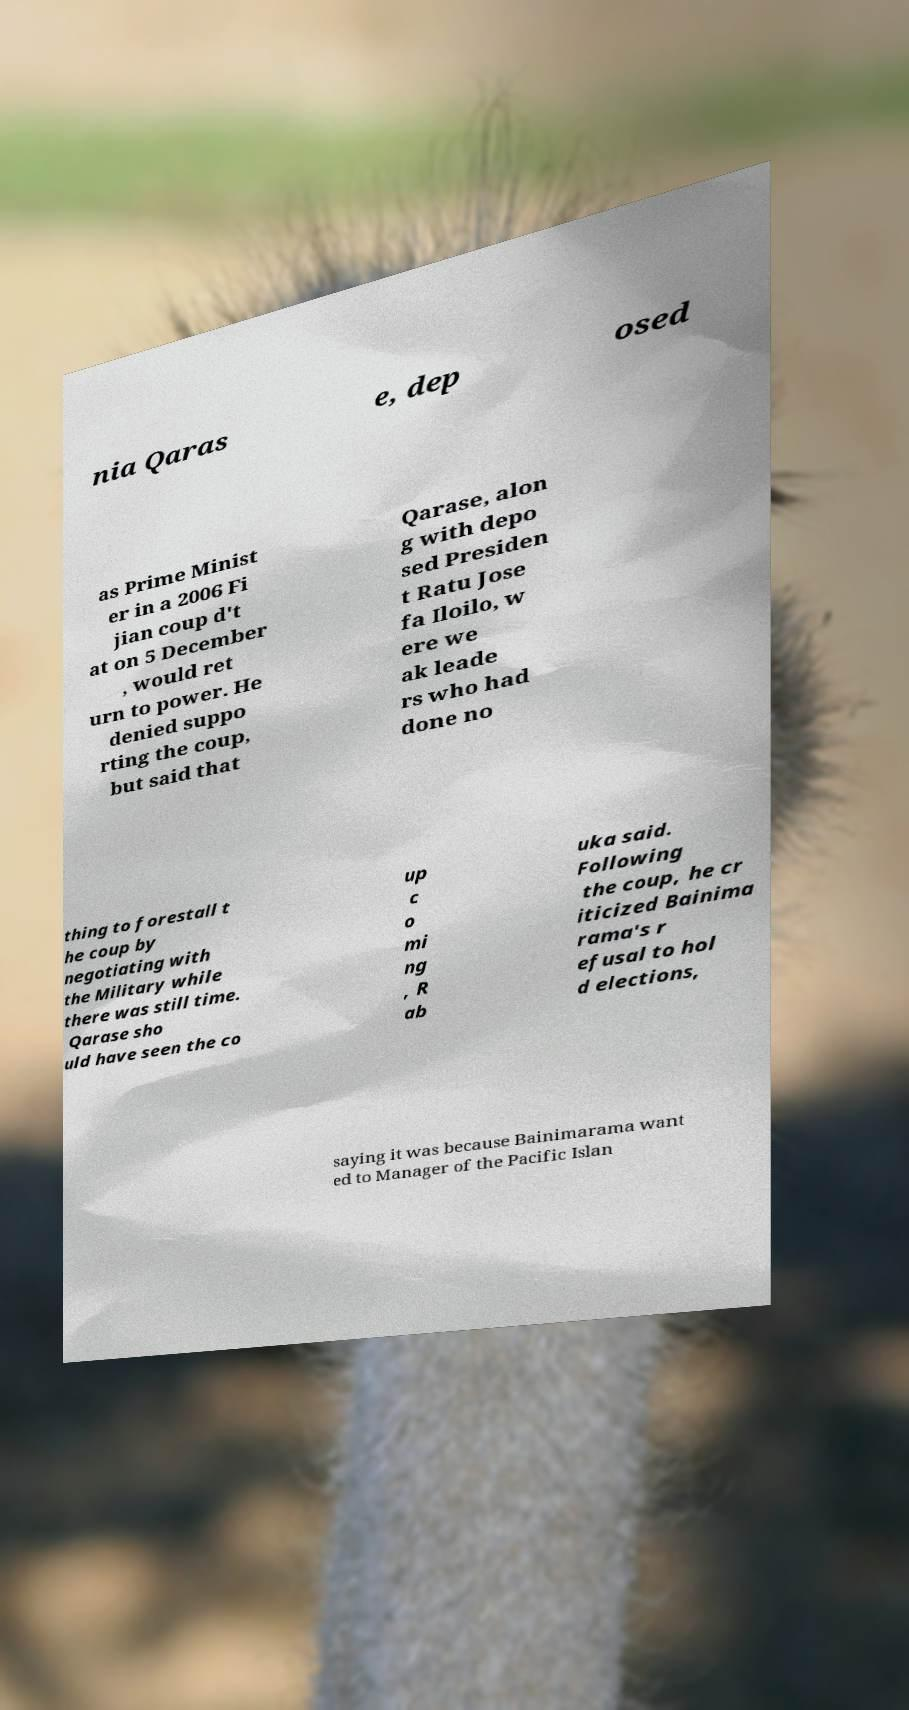Please read and relay the text visible in this image. What does it say? nia Qaras e, dep osed as Prime Minist er in a 2006 Fi jian coup d't at on 5 December , would ret urn to power. He denied suppo rting the coup, but said that Qarase, alon g with depo sed Presiden t Ratu Jose fa Iloilo, w ere we ak leade rs who had done no thing to forestall t he coup by negotiating with the Military while there was still time. Qarase sho uld have seen the co up c o mi ng , R ab uka said. Following the coup, he cr iticized Bainima rama's r efusal to hol d elections, saying it was because Bainimarama want ed to Manager of the Pacific Islan 